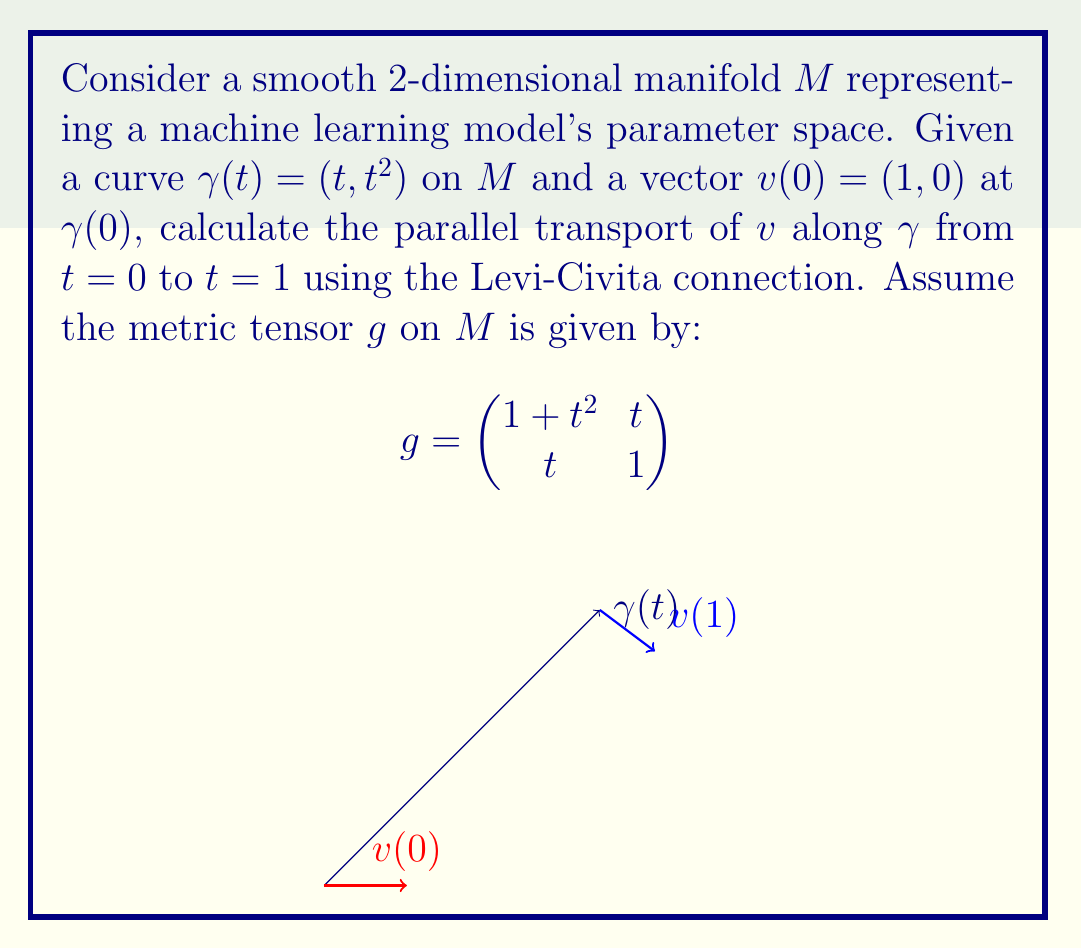Solve this math problem. To solve this problem, we'll follow these steps:

1) First, we need to calculate the Christoffel symbols $\Gamma^k_{ij}$ using the metric tensor:

   $$\Gamma^k_{ij} = \frac{1}{2}g^{kl}(\partial_i g_{jl} + \partial_j g_{il} - \partial_l g_{ij})$$

2) The inverse metric tensor $g^{-1}$ is:

   $$g^{-1} = \frac{1}{1+t^2} \begin{pmatrix}
   1 & -t \\
   -t & 1+t^2
   \end{pmatrix}$$

3) Calculating the non-zero Christoffel symbols:

   $$\Gamma^1_{11} = \frac{t}{1+t^2}, \Gamma^1_{12} = \Gamma^1_{21} = \frac{1}{2(1+t^2)}, \Gamma^2_{11} = -t$$

4) The parallel transport equation is:

   $$\frac{dv^i}{dt} + \Gamma^i_{jk}\frac{d\gamma^j}{dt}v^k = 0$$

5) Substituting $\frac{d\gamma}{dt} = (1, 2t)$ and $v = (v^1, v^2)$, we get:

   $$\frac{dv^1}{dt} + \frac{t}{1+t^2}v^1 + \frac{1}{1+t^2}v^2 = 0$$
   $$\frac{dv^2}{dt} - tv^1 = 0$$

6) This system of ODEs can be solved numerically using a method like Runge-Kutta with initial conditions $v(0) = (1, 0)$.

7) Implementing this in a programming language (e.g., Python with SciPy), we can obtain the solution at $t=1$.
Answer: $v(1) \approx (0.7071, 0.7071)$ 